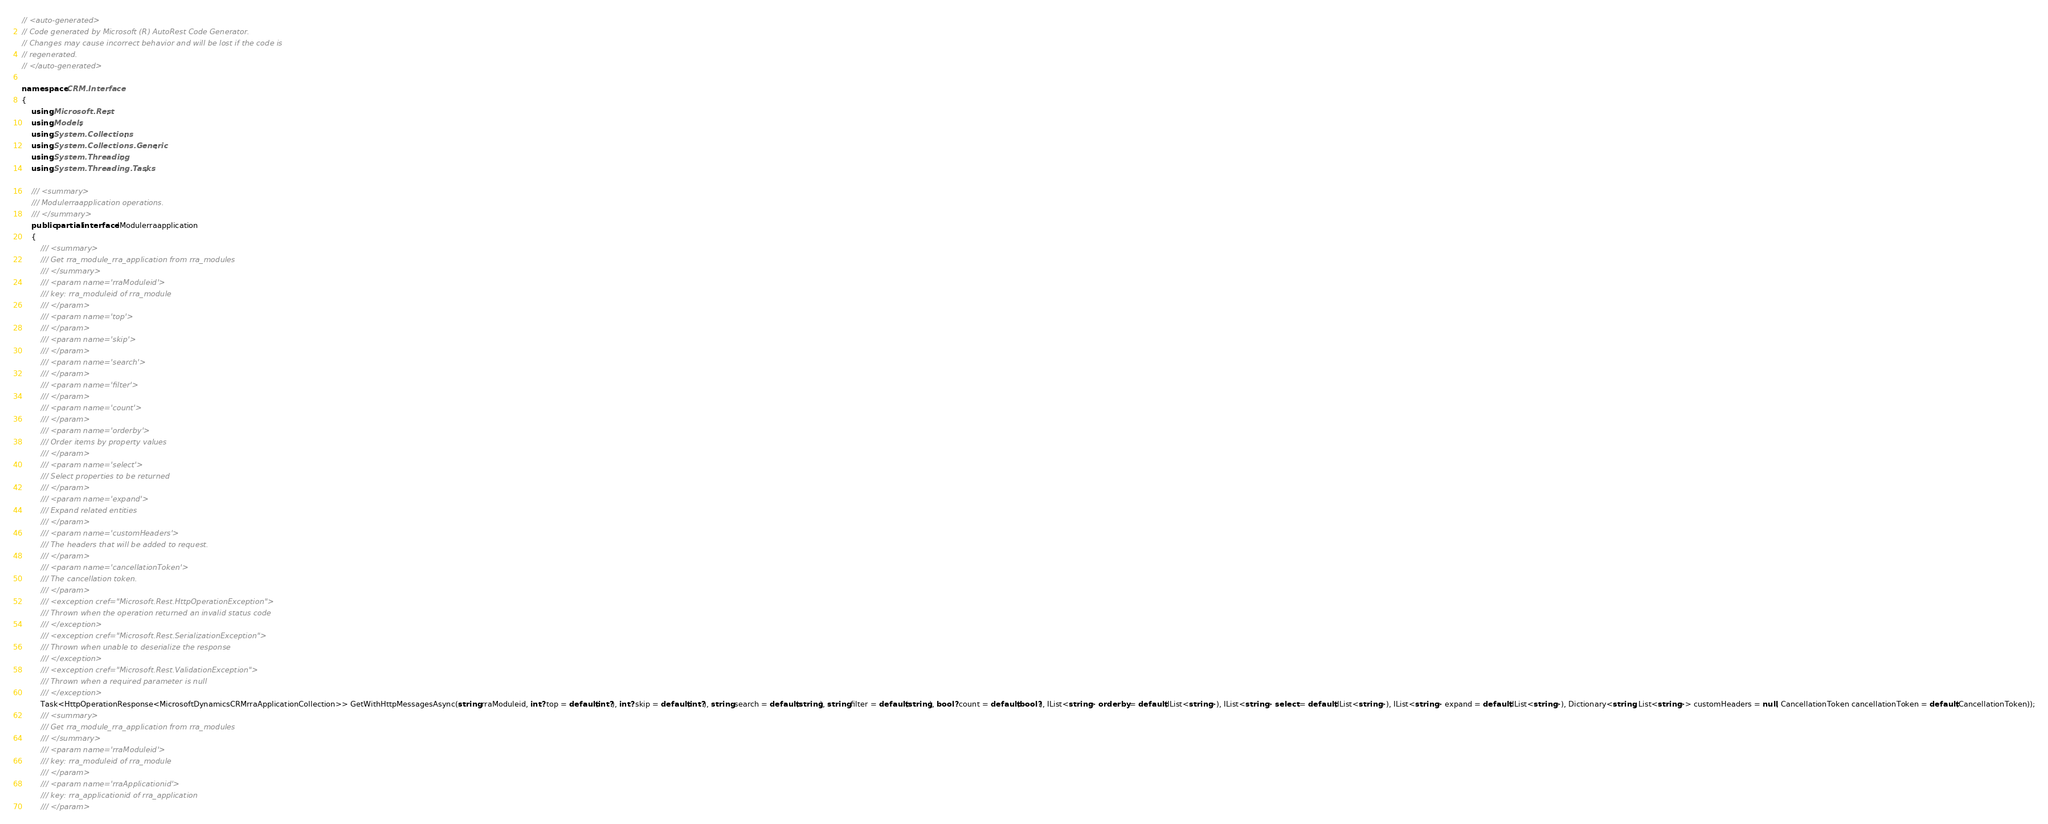Convert code to text. <code><loc_0><loc_0><loc_500><loc_500><_C#_>// <auto-generated>
// Code generated by Microsoft (R) AutoRest Code Generator.
// Changes may cause incorrect behavior and will be lost if the code is
// regenerated.
// </auto-generated>

namespace CRM.Interface
{
    using Microsoft.Rest;
    using Models;
    using System.Collections;
    using System.Collections.Generic;
    using System.Threading;
    using System.Threading.Tasks;

    /// <summary>
    /// Modulerraapplication operations.
    /// </summary>
    public partial interface IModulerraapplication
    {
        /// <summary>
        /// Get rra_module_rra_application from rra_modules
        /// </summary>
        /// <param name='rraModuleid'>
        /// key: rra_moduleid of rra_module
        /// </param>
        /// <param name='top'>
        /// </param>
        /// <param name='skip'>
        /// </param>
        /// <param name='search'>
        /// </param>
        /// <param name='filter'>
        /// </param>
        /// <param name='count'>
        /// </param>
        /// <param name='orderby'>
        /// Order items by property values
        /// </param>
        /// <param name='select'>
        /// Select properties to be returned
        /// </param>
        /// <param name='expand'>
        /// Expand related entities
        /// </param>
        /// <param name='customHeaders'>
        /// The headers that will be added to request.
        /// </param>
        /// <param name='cancellationToken'>
        /// The cancellation token.
        /// </param>
        /// <exception cref="Microsoft.Rest.HttpOperationException">
        /// Thrown when the operation returned an invalid status code
        /// </exception>
        /// <exception cref="Microsoft.Rest.SerializationException">
        /// Thrown when unable to deserialize the response
        /// </exception>
        /// <exception cref="Microsoft.Rest.ValidationException">
        /// Thrown when a required parameter is null
        /// </exception>
        Task<HttpOperationResponse<MicrosoftDynamicsCRMrraApplicationCollection>> GetWithHttpMessagesAsync(string rraModuleid, int? top = default(int?), int? skip = default(int?), string search = default(string), string filter = default(string), bool? count = default(bool?), IList<string> orderby = default(IList<string>), IList<string> select = default(IList<string>), IList<string> expand = default(IList<string>), Dictionary<string, List<string>> customHeaders = null, CancellationToken cancellationToken = default(CancellationToken));
        /// <summary>
        /// Get rra_module_rra_application from rra_modules
        /// </summary>
        /// <param name='rraModuleid'>
        /// key: rra_moduleid of rra_module
        /// </param>
        /// <param name='rraApplicationid'>
        /// key: rra_applicationid of rra_application
        /// </param></code> 